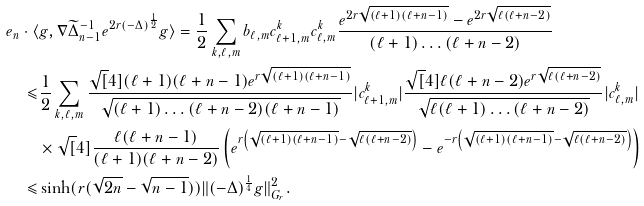Convert formula to latex. <formula><loc_0><loc_0><loc_500><loc_500>e _ { n } \cdot \langle & g , \nabla \widetilde { \Delta } ^ { - 1 } _ { n - 1 } e ^ { 2 r ( - \Delta ) ^ { \frac { 1 } { 2 } } } g \rangle = \frac { 1 } { 2 } \sum _ { k , \ell , m } b _ { \ell , m } c _ { \ell + 1 , m } ^ { k } c _ { \ell , m } ^ { k } \frac { e ^ { 2 r \sqrt { ( \ell + 1 ) ( \ell + n - 1 ) } } - e ^ { 2 r \sqrt { \ell ( \ell + n - 2 ) } } } { ( \ell + 1 ) \dots ( \ell + n - 2 ) } \\ \leqslant & \frac { 1 } { 2 } \sum _ { k , \ell , m } \frac { \sqrt { [ } 4 ] { ( \ell + 1 ) ( \ell + n - 1 ) } e ^ { r \sqrt { ( \ell + 1 ) ( \ell + n - 1 ) } } } { \sqrt { ( \ell + 1 ) \dots ( \ell + n - 2 ) ( \ell + n - 1 ) } } | c _ { \ell + 1 , m } ^ { k } | \frac { \sqrt { [ } 4 ] { \ell ( \ell + n - 2 ) } e ^ { r \sqrt { \ell ( \ell + n - 2 ) } } } { \sqrt { \ell ( \ell + 1 ) \dots ( \ell + n - 2 ) } } | c _ { \ell , m } ^ { k } | \\ & \times \sqrt { [ } 4 ] { \frac { \ell ( \ell + n - 1 ) } { ( \ell + 1 ) ( \ell + n - 2 ) } } \left ( e ^ { r \left ( \sqrt { ( \ell + 1 ) ( \ell + n - 1 ) } - \sqrt { \ell ( \ell + n - 2 ) } \right ) } - e ^ { - r \left ( \sqrt { ( \ell + 1 ) ( \ell + n - 1 ) } - \sqrt { \ell ( \ell + n - 2 ) } \right ) } \right ) \\ \leqslant & \sinh ( r ( \sqrt { 2 n } - \sqrt { n - 1 } ) ) \| ( - \Delta ) ^ { \frac { 1 } { 4 } } g \| ^ { 2 } _ { G _ { r } } .</formula> 